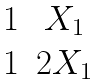<formula> <loc_0><loc_0><loc_500><loc_500>\begin{matrix} 1 & X _ { 1 } \\ 1 & 2 X _ { 1 } \end{matrix}</formula> 